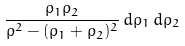<formula> <loc_0><loc_0><loc_500><loc_500>\frac { { \rho } _ { 1 } { \rho } _ { 2 } } { { \rho } ^ { 2 } - ( { \rho } _ { 1 } + { \rho } _ { 2 } ) ^ { 2 } } \, d { \rho } _ { 1 } \, d { \rho } _ { 2 }</formula> 